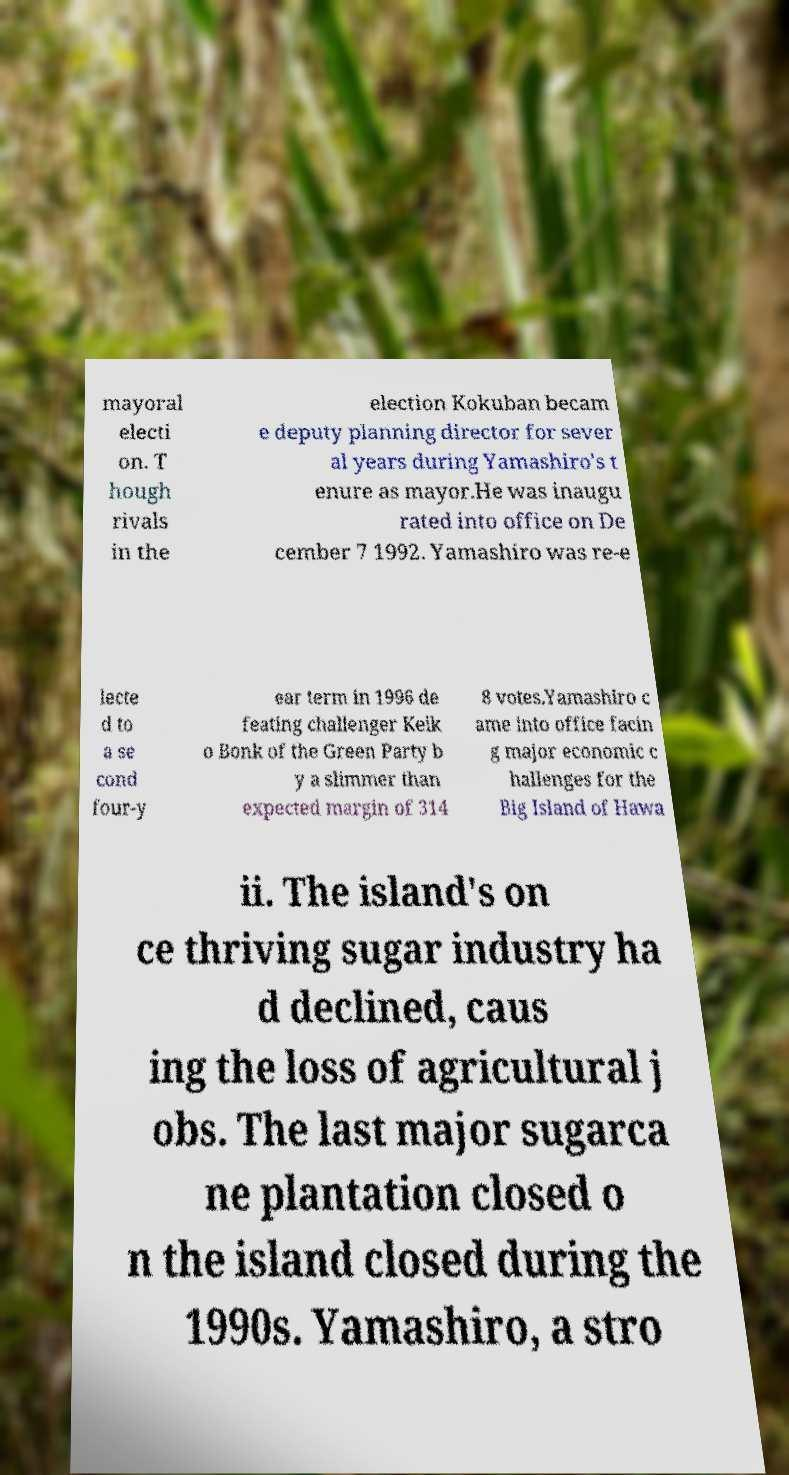Please read and relay the text visible in this image. What does it say? mayoral electi on. T hough rivals in the election Kokuban becam e deputy planning director for sever al years during Yamashiro's t enure as mayor.He was inaugu rated into office on De cember 7 1992. Yamashiro was re-e lecte d to a se cond four-y ear term in 1996 de feating challenger Keik o Bonk of the Green Party b y a slimmer than expected margin of 314 8 votes.Yamashiro c ame into office facin g major economic c hallenges for the Big Island of Hawa ii. The island's on ce thriving sugar industry ha d declined, caus ing the loss of agricultural j obs. The last major sugarca ne plantation closed o n the island closed during the 1990s. Yamashiro, a stro 